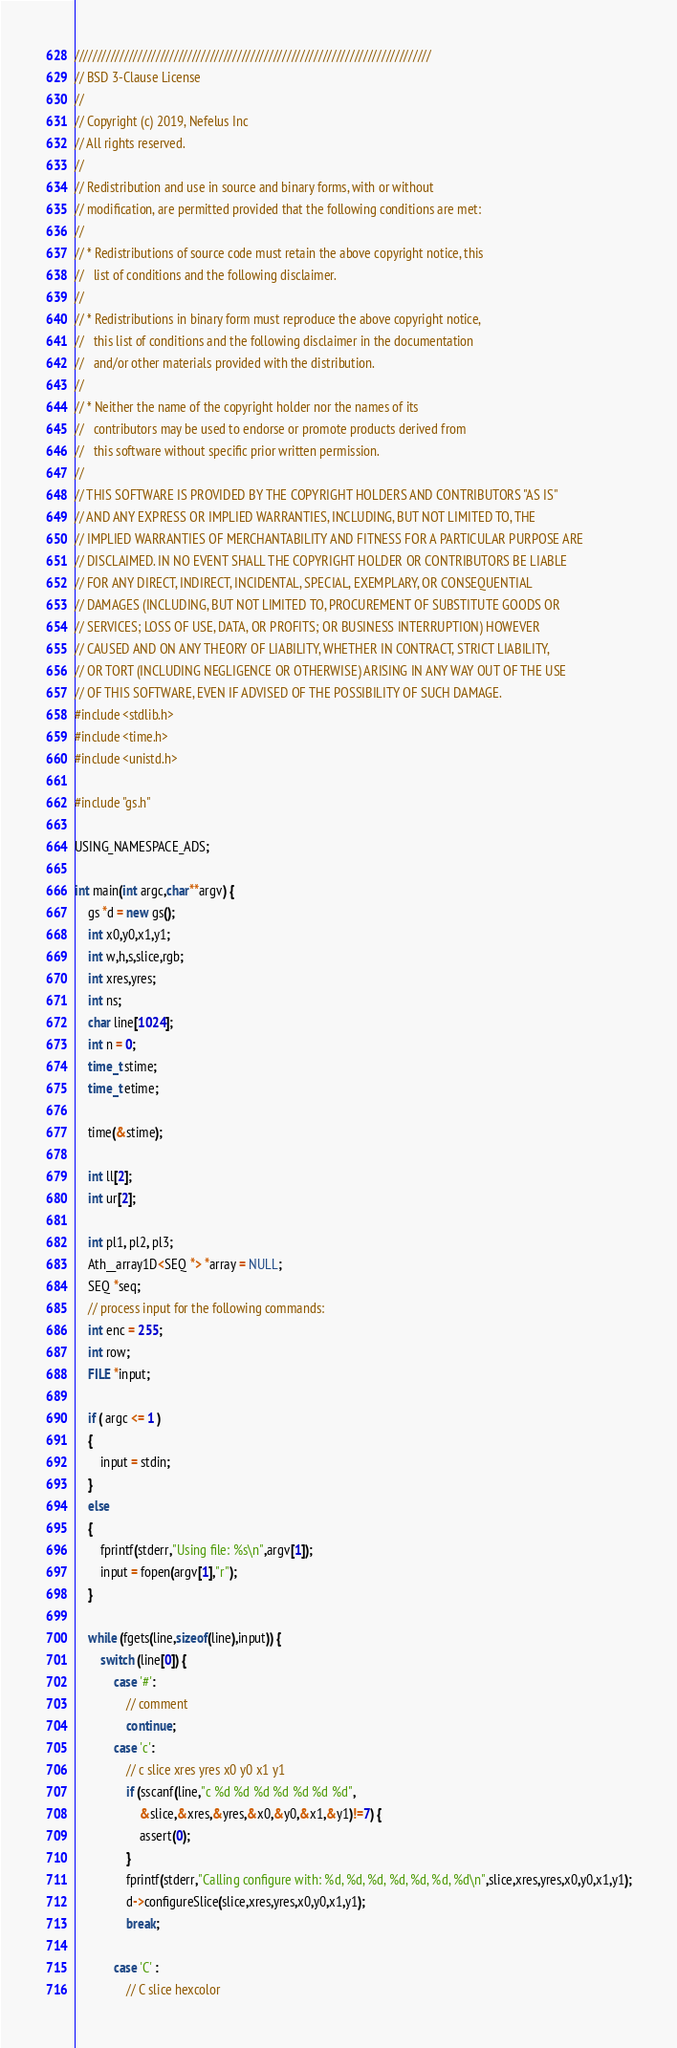Convert code to text. <code><loc_0><loc_0><loc_500><loc_500><_C++_>///////////////////////////////////////////////////////////////////////////////
// BSD 3-Clause License
//
// Copyright (c) 2019, Nefelus Inc
// All rights reserved.
//
// Redistribution and use in source and binary forms, with or without
// modification, are permitted provided that the following conditions are met:
//
// * Redistributions of source code must retain the above copyright notice, this
//   list of conditions and the following disclaimer.
//
// * Redistributions in binary form must reproduce the above copyright notice,
//   this list of conditions and the following disclaimer in the documentation
//   and/or other materials provided with the distribution.
//
// * Neither the name of the copyright holder nor the names of its
//   contributors may be used to endorse or promote products derived from
//   this software without specific prior written permission.
//
// THIS SOFTWARE IS PROVIDED BY THE COPYRIGHT HOLDERS AND CONTRIBUTORS "AS IS"
// AND ANY EXPRESS OR IMPLIED WARRANTIES, INCLUDING, BUT NOT LIMITED TO, THE
// IMPLIED WARRANTIES OF MERCHANTABILITY AND FITNESS FOR A PARTICULAR PURPOSE ARE
// DISCLAIMED. IN NO EVENT SHALL THE COPYRIGHT HOLDER OR CONTRIBUTORS BE LIABLE
// FOR ANY DIRECT, INDIRECT, INCIDENTAL, SPECIAL, EXEMPLARY, OR CONSEQUENTIAL
// DAMAGES (INCLUDING, BUT NOT LIMITED TO, PROCUREMENT OF SUBSTITUTE GOODS OR
// SERVICES; LOSS OF USE, DATA, OR PROFITS; OR BUSINESS INTERRUPTION) HOWEVER
// CAUSED AND ON ANY THEORY OF LIABILITY, WHETHER IN CONTRACT, STRICT LIABILITY,
// OR TORT (INCLUDING NEGLIGENCE OR OTHERWISE) ARISING IN ANY WAY OUT OF THE USE
// OF THIS SOFTWARE, EVEN IF ADVISED OF THE POSSIBILITY OF SUCH DAMAGE.
#include <stdlib.h>
#include <time.h>
#include <unistd.h>

#include "gs.h"

USING_NAMESPACE_ADS;

int main(int argc,char**argv) {
	gs *d = new gs();
	int x0,y0,x1,y1;
	int w,h,s,slice,rgb;
    int xres,yres;
    int ns;
	char line[1024];
	int n = 0;
	time_t stime;
	time_t etime;

	time(&stime);

    int ll[2];
    int ur[2];

    int pl1, pl2, pl3;
    Ath__array1D<SEQ *> *array = NULL;
    SEQ *seq;
	// process input for the following commands:
    int enc = 255;
    int row;
    FILE *input;

    if ( argc <= 1 )
    {
        input = stdin;
    }
    else
    {
        fprintf(stderr,"Using file: %s\n",argv[1]);
        input = fopen(argv[1],"r");
    }

	while (fgets(line,sizeof(line),input)) {
		switch (line[0]) {
            case '#':
                // comment
                continue;
			case 'c': 
				// c slice xres yres x0 y0 x1 y1 
				if (sscanf(line,"c %d %d %d %d %d %d %d",
					&slice,&xres,&yres,&x0,&y0,&x1,&y1)!=7) {
					assert(0);
				}
                fprintf(stderr,"Calling configure with: %d, %d, %d, %d, %d, %d, %d\n",slice,xres,yres,x0,y0,x1,y1);
				d->configureSlice(slice,xres,yres,x0,y0,x1,y1);
				break;

			case 'C' : 
				// C slice hexcolor</code> 